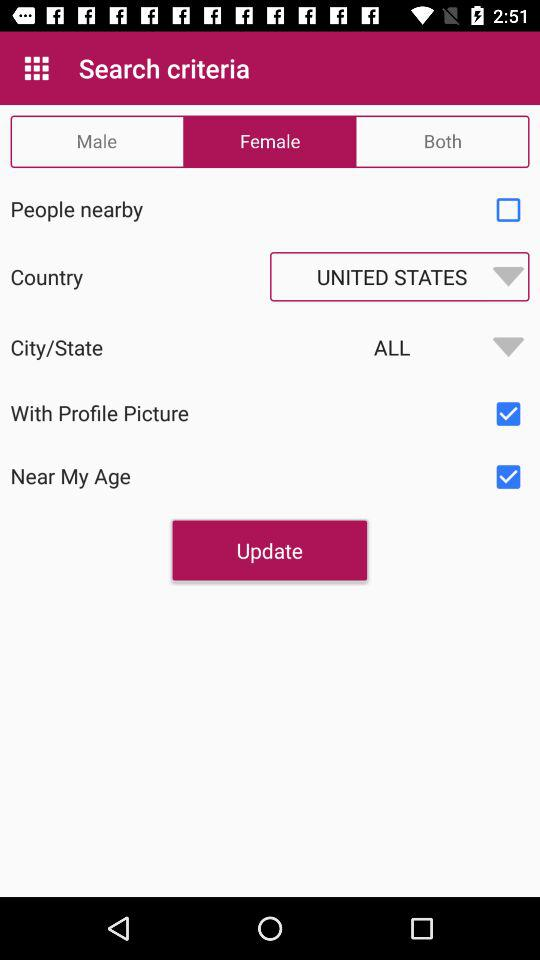Which gender is selected? The selected gender is female. 